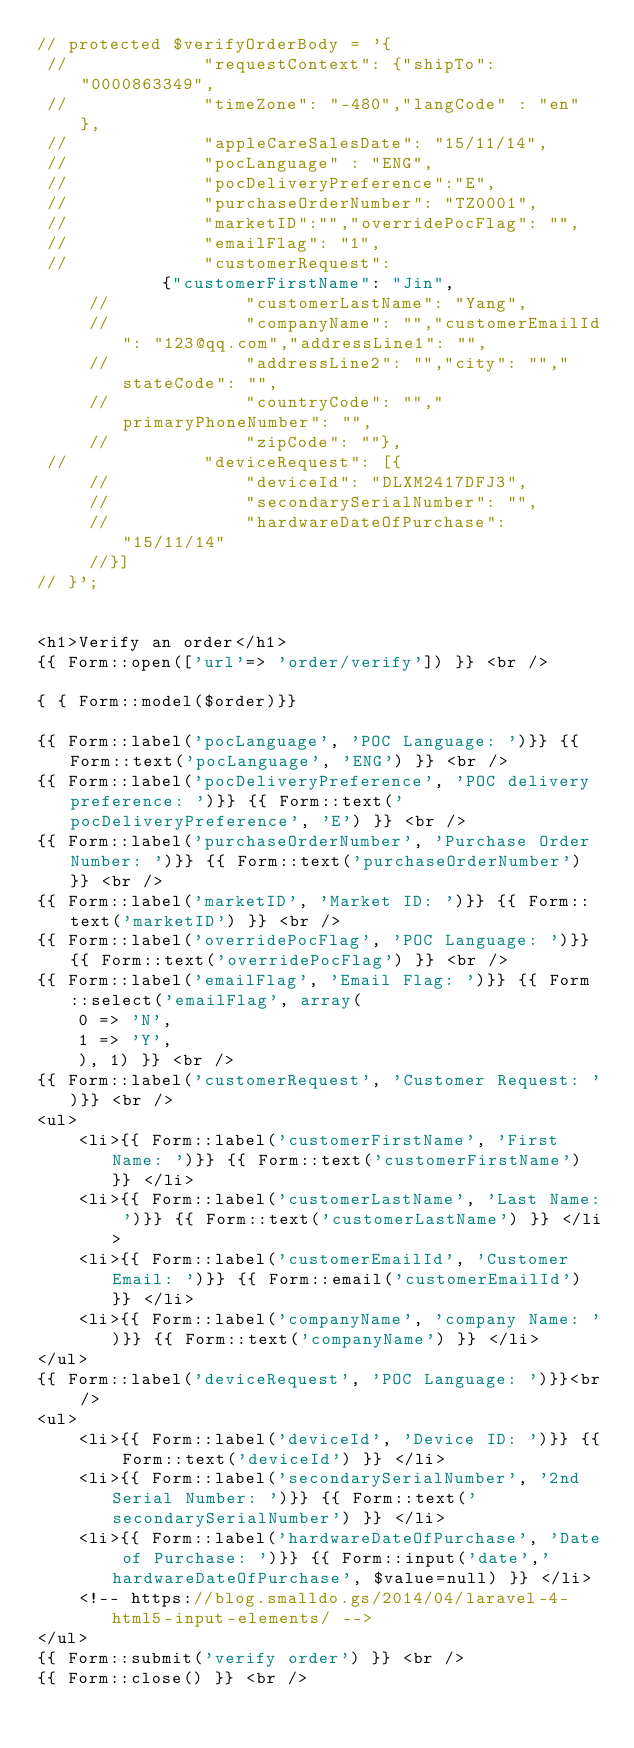Convert code to text. <code><loc_0><loc_0><loc_500><loc_500><_PHP_>// protected $verifyOrderBody = '{
 //            	"requestContext": {"shipTo": "0000863349",
 //            	"timeZone": "-480","langCode" : "en" },
 //            	"appleCareSalesDate": "15/11/14",
 //            	"pocLanguage" : "ENG",
 //            	"pocDeliveryPreference":"E",
 //            	"purchaseOrderNumber": "TZ0001",
 //            	"marketID":"","overridePocFlag": "",
 //            	"emailFlag": "1",
 //            	"customerRequest": 
 			{"customerFirstName": "Jin",
	 //            	"customerLastName": "Yang",
	 //            	"companyName": "","customerEmailId": "123@qq.com","addressLine1": "",
	 //            	"addressLine2": "","city": "","stateCode": "",
	 //            	"countryCode": "","primaryPhoneNumber": "",
	 //            	"zipCode": ""},
 //            	"deviceRequest": [{
	 //            	"deviceId": "DLXM2417DFJ3",
	 //            	"secondarySerialNumber": "",
	 //            	"hardwareDateOfPurchase": "15/11/14"
	 //}]
// }';


<h1>Verify an order</h1>
{{ Form::open(['url'=> 'order/verify']) }} <br />

{ { Form::model($order)}}

{{ Form::label('pocLanguage', 'POC Language: ')}} {{ Form::text('pocLanguage', 'ENG') }} <br />
{{ Form::label('pocDeliveryPreference', 'POC delivery preference: ')}} {{ Form::text('pocDeliveryPreference', 'E') }} <br />
{{ Form::label('purchaseOrderNumber', 'Purchase Order Number: ')}} {{ Form::text('purchaseOrderNumber') }} <br />
{{ Form::label('marketID', 'Market ID: ')}} {{ Form::text('marketID') }} <br />
{{ Form::label('overridePocFlag', 'POC Language: ')}} {{ Form::text('overridePocFlag') }} <br />
{{ Form::label('emailFlag', 'Email Flag: ')}} {{ Form::select('emailFlag', array(
	0 => 'N',
	1 => 'Y',
	), 1) }} <br />
{{ Form::label('customerRequest', 'Customer Request: ')}} <br />
<ul>
	<li>{{ Form::label('customerFirstName', 'First Name: ')}} {{ Form::text('customerFirstName') }} </li>
	<li>{{ Form::label('customerLastName', 'Last Name: ')}} {{ Form::text('customerLastName') }} </li>
	<li>{{ Form::label('customerEmailId', 'Customer Email: ')}} {{ Form::email('customerEmailId') }} </li>
	<li>{{ Form::label('companyName', 'company Name: ')}} {{ Form::text('companyName') }} </li>
</ul>
{{ Form::label('deviceRequest', 'POC Language: ')}}<br />
<ul>
	<li>{{ Form::label('deviceId', 'Device ID: ')}} {{ Form::text('deviceId') }} </li>
	<li>{{ Form::label('secondarySerialNumber', '2nd Serial Number: ')}} {{ Form::text('secondarySerialNumber') }} </li>
	<li>{{ Form::label('hardwareDateOfPurchase', 'Date of Purchase: ')}} {{ Form::input('date','hardwareDateOfPurchase', $value=null) }} </li>
	<!-- https://blog.smalldo.gs/2014/04/laravel-4-html5-input-elements/ -->
</ul>
{{ Form::submit('verify order') }} <br />
{{ Form::close() }} <br /></code> 